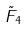Convert formula to latex. <formula><loc_0><loc_0><loc_500><loc_500>\tilde { F } _ { 4 }</formula> 